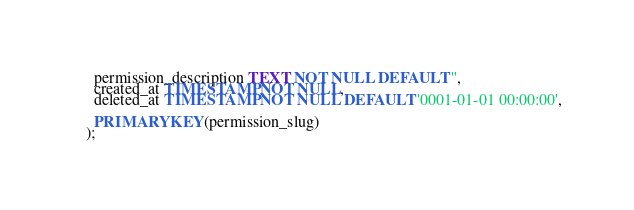<code> <loc_0><loc_0><loc_500><loc_500><_SQL_>  permission_description TEXT NOT NULL DEFAULT '',
  created_at TIMESTAMP NOT NULL,
  deleted_at TIMESTAMP NOT NULL DEFAULT '0001-01-01 00:00:00',

  PRIMARY KEY(permission_slug)
);
</code> 